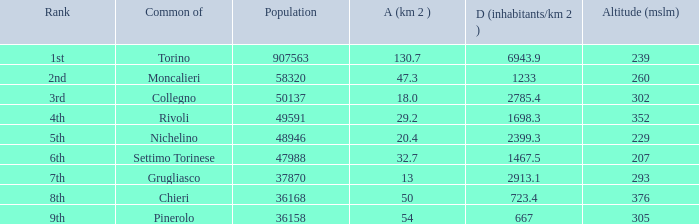What is the name of the 9th ranked common? Pinerolo. 